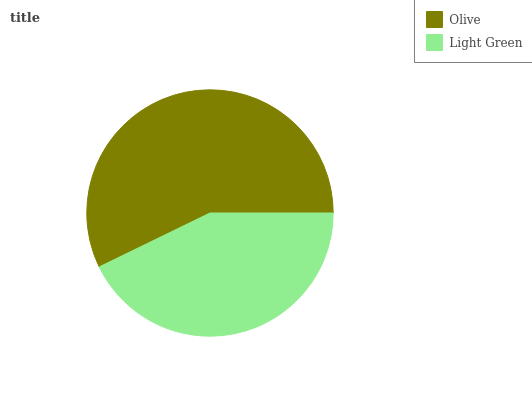Is Light Green the minimum?
Answer yes or no. Yes. Is Olive the maximum?
Answer yes or no. Yes. Is Light Green the maximum?
Answer yes or no. No. Is Olive greater than Light Green?
Answer yes or no. Yes. Is Light Green less than Olive?
Answer yes or no. Yes. Is Light Green greater than Olive?
Answer yes or no. No. Is Olive less than Light Green?
Answer yes or no. No. Is Olive the high median?
Answer yes or no. Yes. Is Light Green the low median?
Answer yes or no. Yes. Is Light Green the high median?
Answer yes or no. No. Is Olive the low median?
Answer yes or no. No. 